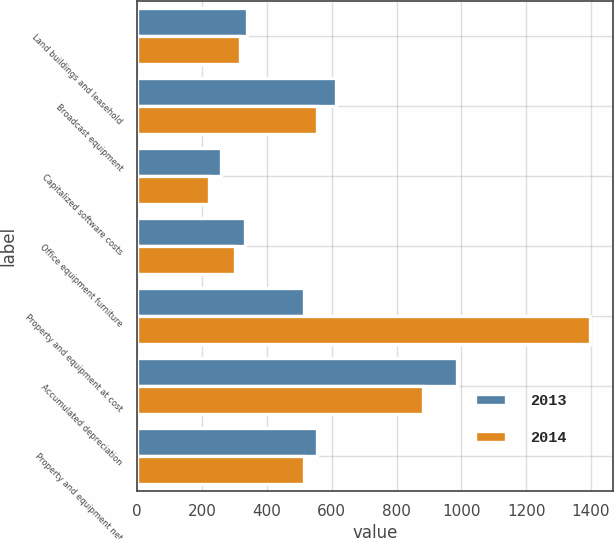<chart> <loc_0><loc_0><loc_500><loc_500><stacked_bar_chart><ecel><fcel>Land buildings and leasehold<fcel>Broadcast equipment<fcel>Capitalized software costs<fcel>Office equipment furniture<fcel>Property and equipment at cost<fcel>Accumulated depreciation<fcel>Property and equipment net<nl><fcel>2013<fcel>340<fcel>612<fcel>258<fcel>332<fcel>514<fcel>988<fcel>554<nl><fcel>2014<fcel>318<fcel>556<fcel>222<fcel>301<fcel>1397<fcel>883<fcel>514<nl></chart> 